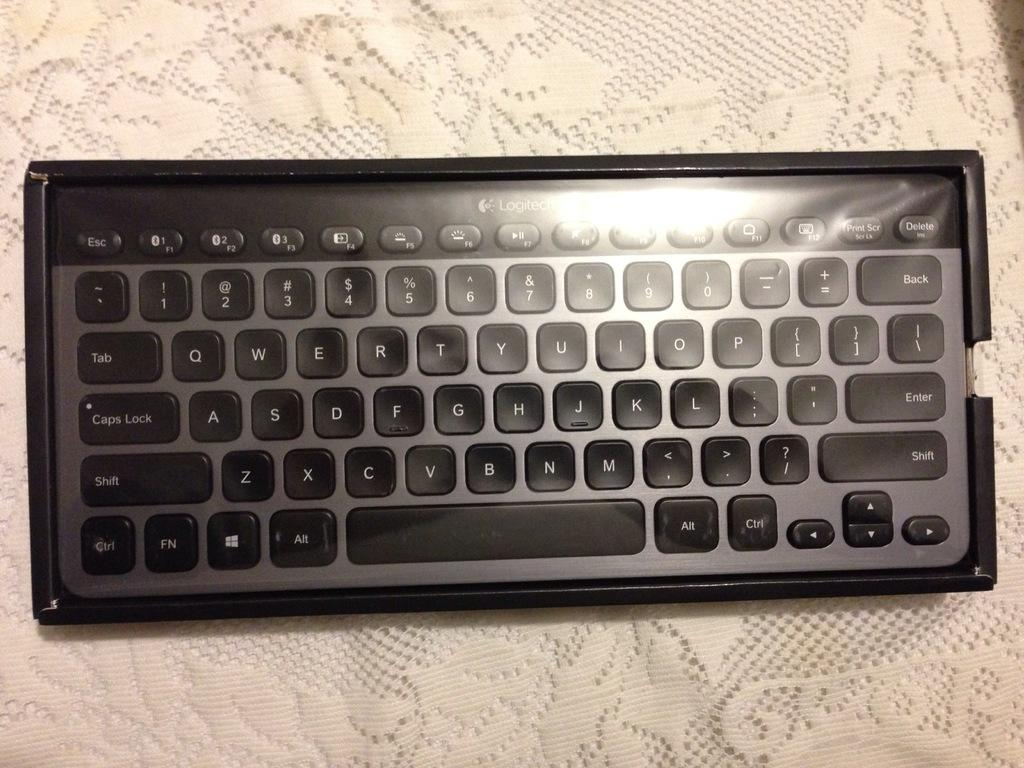<image>
Present a compact description of the photo's key features. Portable Logitech keyboard, still in original box and plastic wrap. 